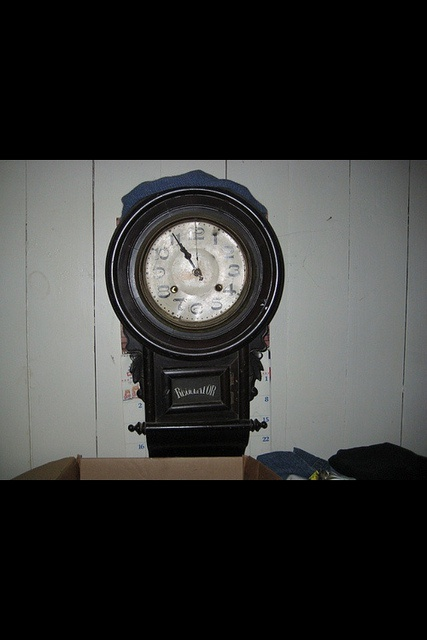Describe the objects in this image and their specific colors. I can see a clock in black, darkgray, lightgray, and gray tones in this image. 